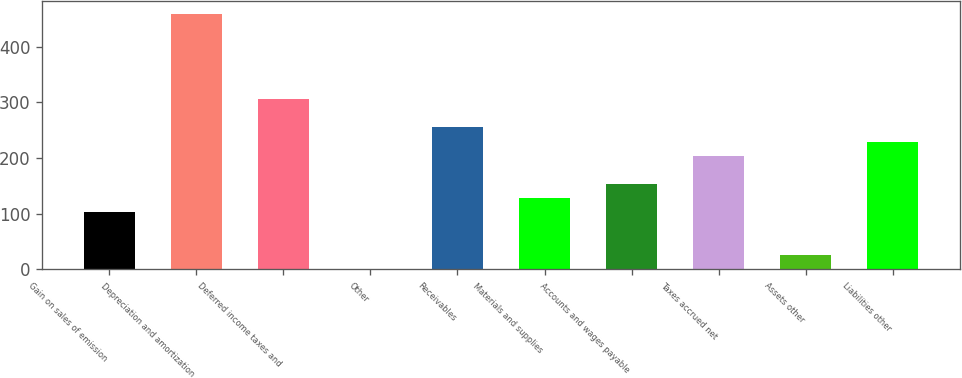Convert chart. <chart><loc_0><loc_0><loc_500><loc_500><bar_chart><fcel>Gain on sales of emission<fcel>Depreciation and amortization<fcel>Deferred income taxes and<fcel>Other<fcel>Receivables<fcel>Materials and supplies<fcel>Accounts and wages payable<fcel>Taxes accrued net<fcel>Assets other<fcel>Liabilities other<nl><fcel>102.6<fcel>458.2<fcel>305.8<fcel>1<fcel>255<fcel>128<fcel>153.4<fcel>204.2<fcel>26.4<fcel>229.6<nl></chart> 